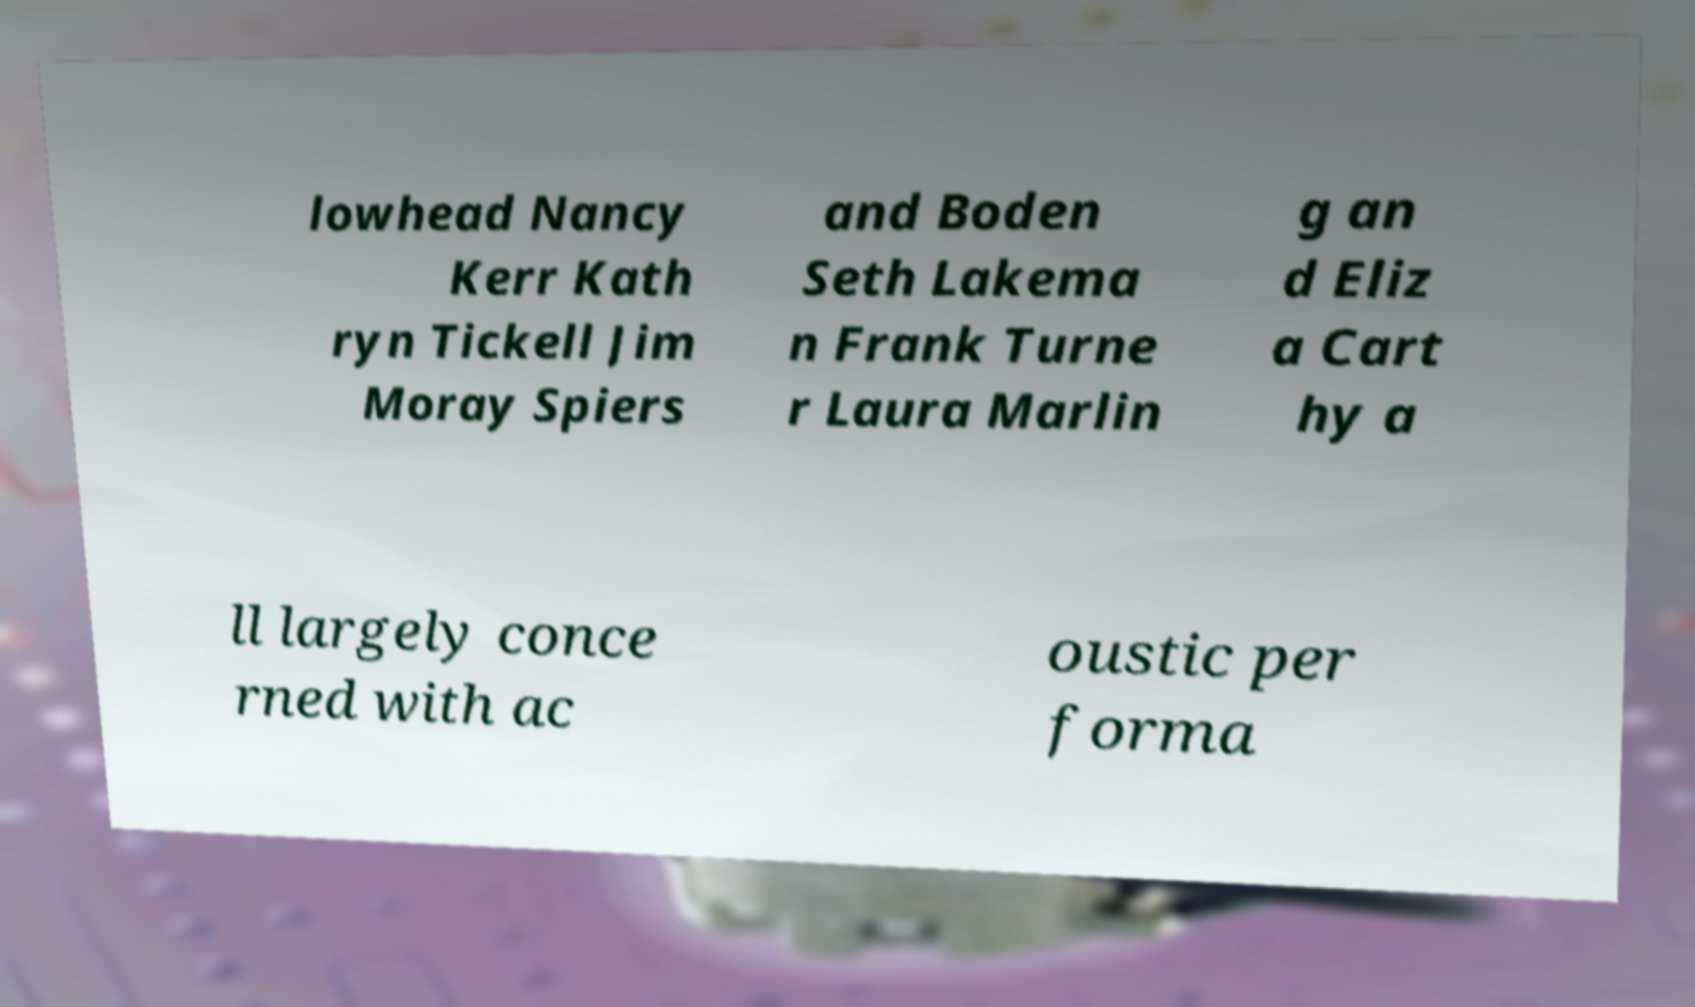Please read and relay the text visible in this image. What does it say? lowhead Nancy Kerr Kath ryn Tickell Jim Moray Spiers and Boden Seth Lakema n Frank Turne r Laura Marlin g an d Eliz a Cart hy a ll largely conce rned with ac oustic per forma 